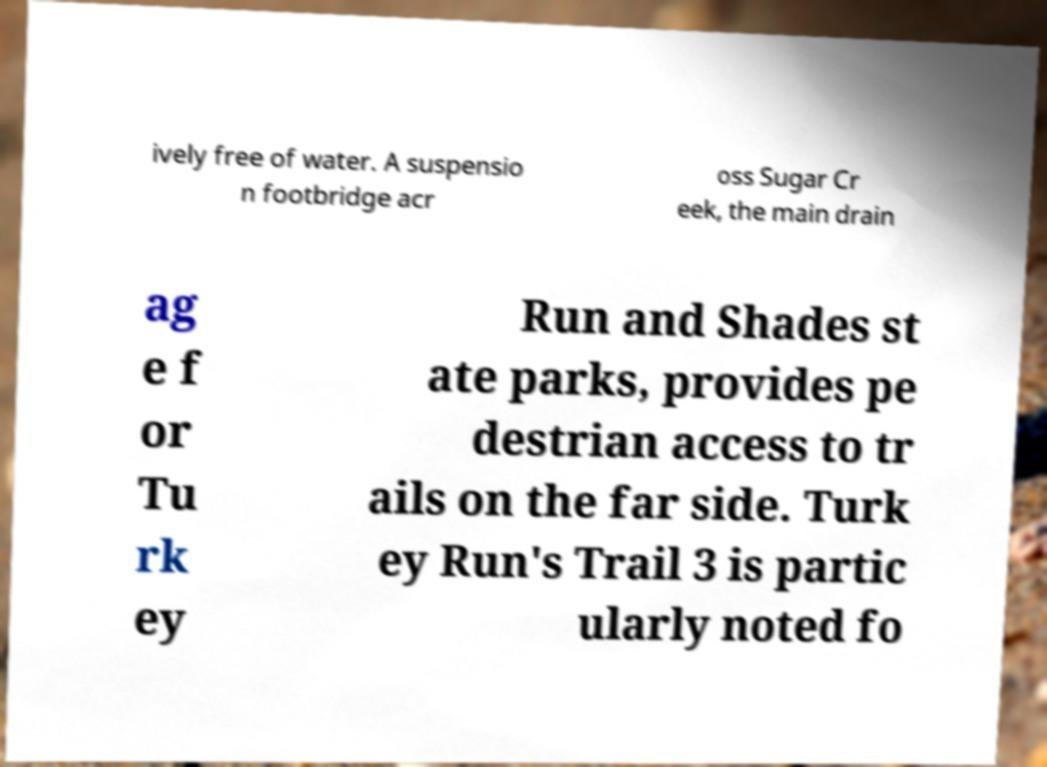Please identify and transcribe the text found in this image. ively free of water. A suspensio n footbridge acr oss Sugar Cr eek, the main drain ag e f or Tu rk ey Run and Shades st ate parks, provides pe destrian access to tr ails on the far side. Turk ey Run's Trail 3 is partic ularly noted fo 